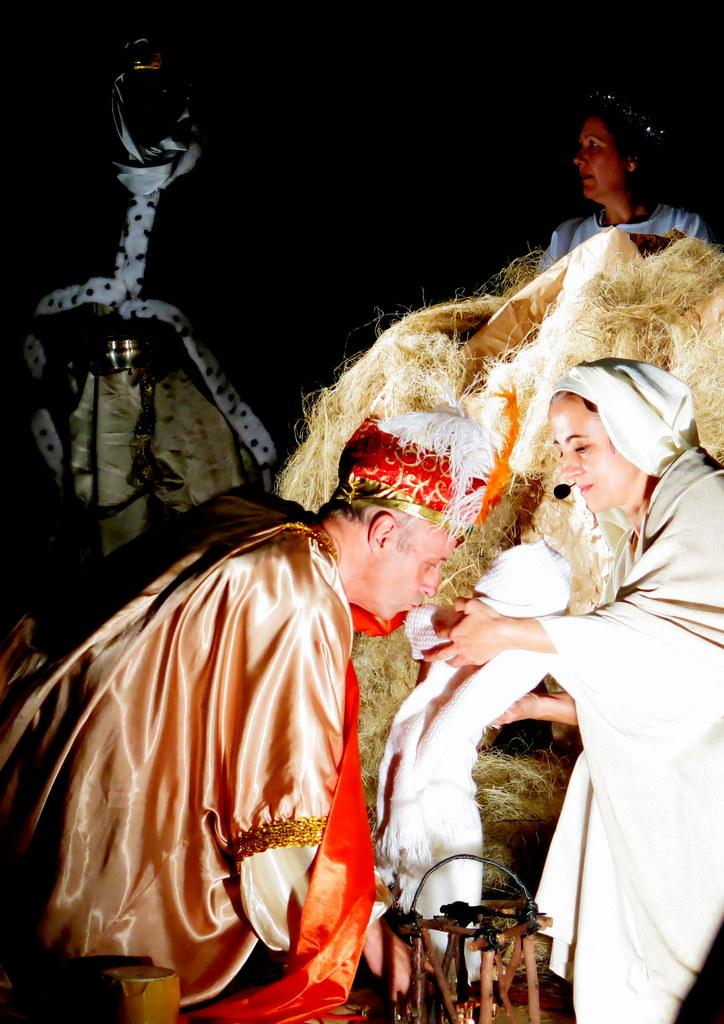What are the people in the image wearing? The people in the image are wearing costumes. What is one of the people holding in the image? One of the people is holding an object. What type of vegetation can be seen in the image? Dry grass is visible in the image. What is located at the bottom of the image? There is a stand at the bottom of the image. What other objects can be seen at the bottom of the image? There are other objects present at the bottom of the image. What type of ink is being used by the person teaching in the image? There is no person teaching in the image, nor is there any ink present. 